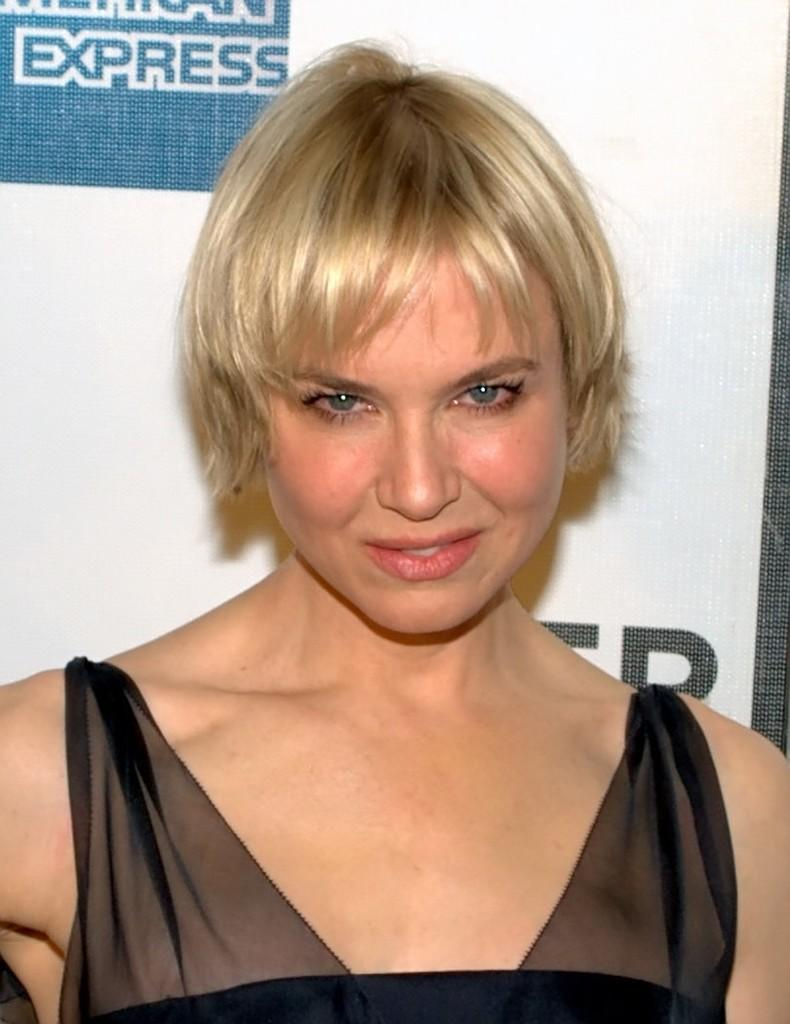What is present in the image? There is a person and a banner with text in the image. Can you describe the banner in the image? Yes, there is a banner with text in the image. How many sheep are visible in the image? There are no sheep present in the image. What type of bead is being used to decorate the banner in the image? There is no mention of beads in the image, as it only features a person and a banner with text. Are there any wings visible on the person in the image? There is no mention of wings on the person in the image. 